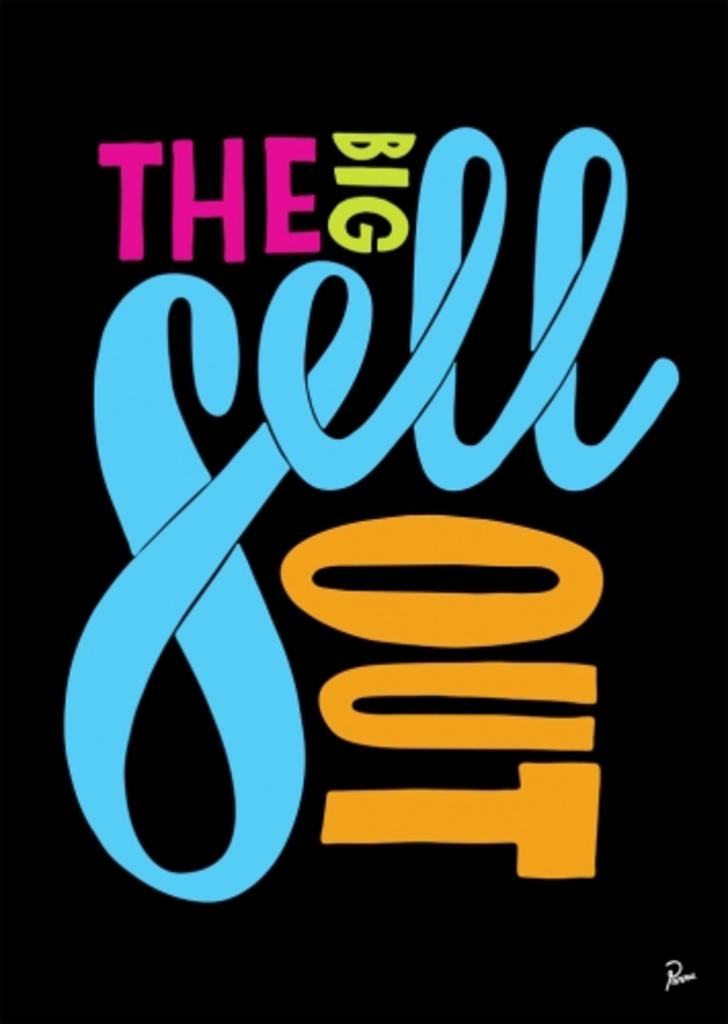<image>
Write a terse but informative summary of the picture. an orange word that says out and other words as well 